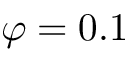Convert formula to latex. <formula><loc_0><loc_0><loc_500><loc_500>\varphi = 0 . 1</formula> 